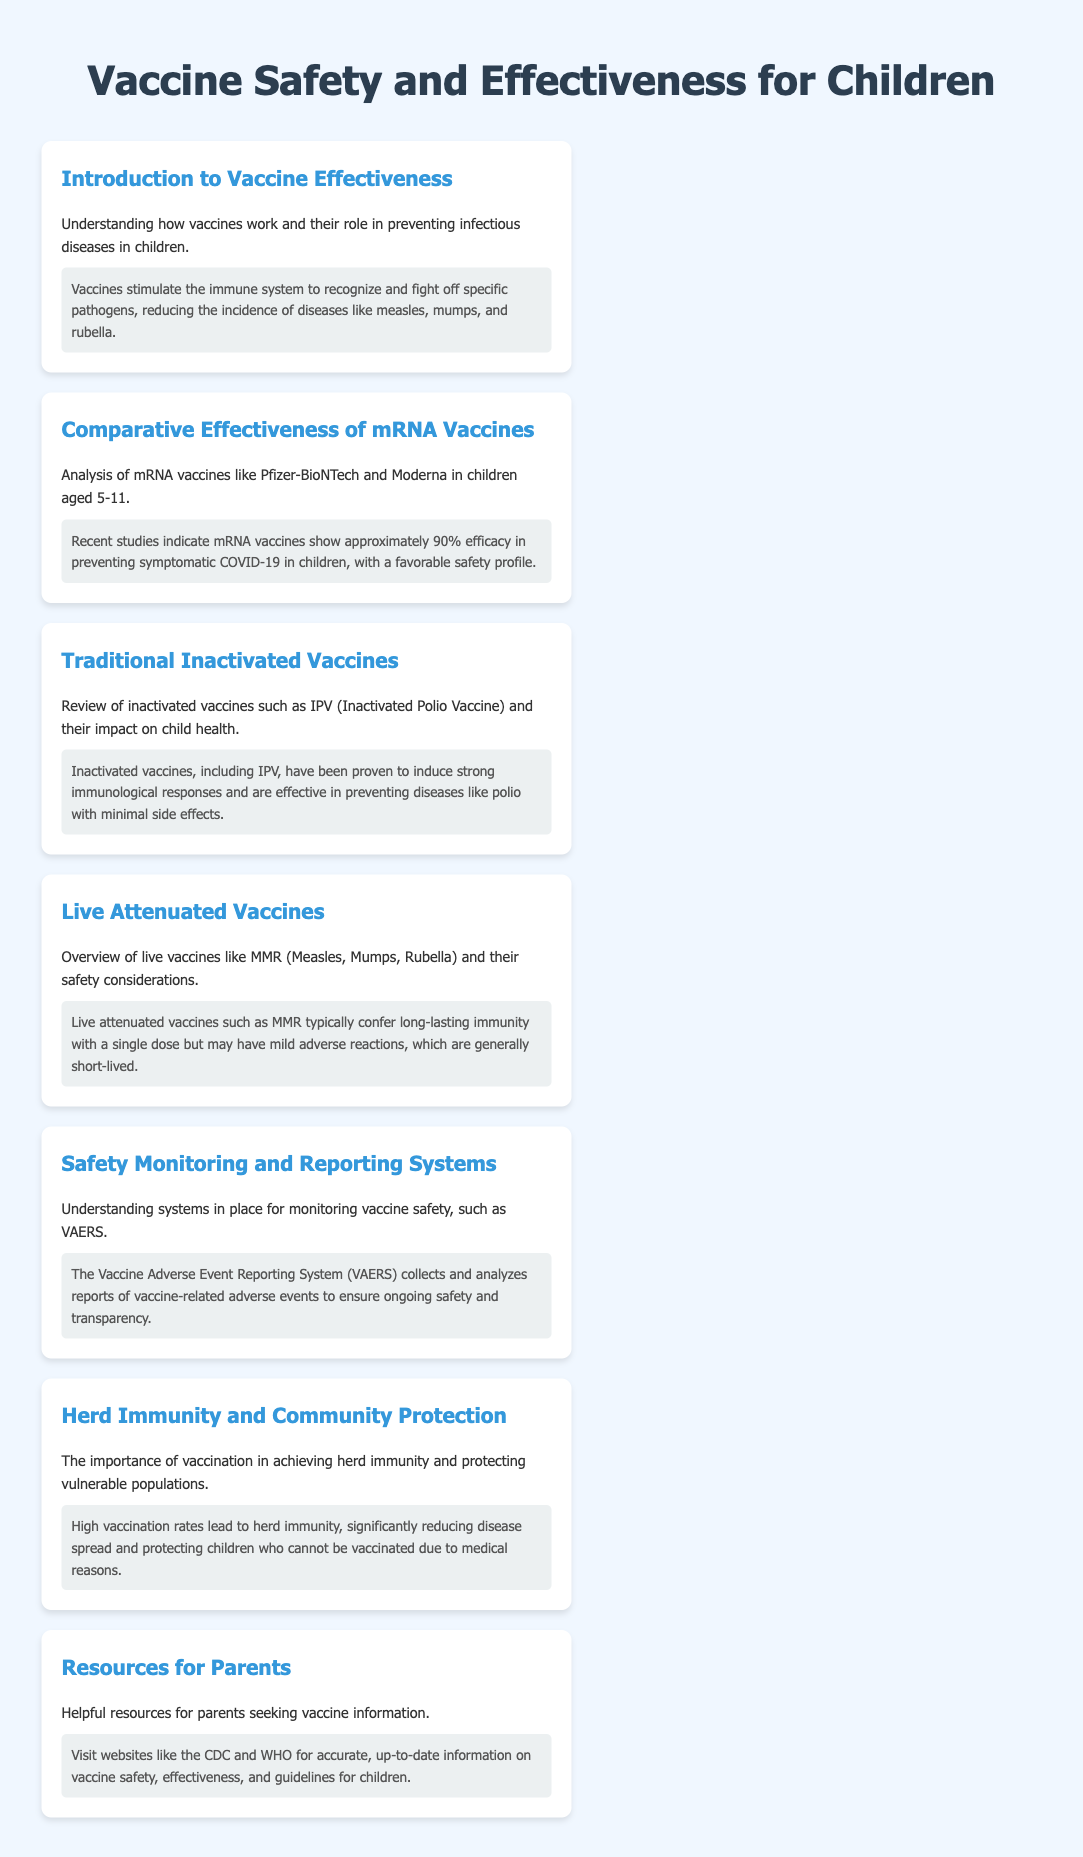What is the efficacy of mRNA vaccines in children? The document states that recent studies indicate mRNA vaccines show approximately 90% efficacy in preventing symptomatic COVID-19 in children.
Answer: 90% What type of vaccine is IPV? IPV is referred to as an inactivated vaccine in the document.
Answer: Inactivated What do live attenuated vaccines like MMR confer? The document states that live attenuated vaccines typically confer long-lasting immunity.
Answer: Long-lasting immunity What does VAERS stand for? The document mentions the Vaccine Adverse Event Reporting System, abbreviated as VAERS.
Answer: VAERS What is the main benefit of high vaccination rates? The document indicates that high vaccination rates lead to herd immunity.
Answer: Herd immunity What can be found on resources like the CDC and WHO? The document suggests that these websites offer accurate, up-to-date information on vaccine safety and effectiveness.
Answer: Vaccine safety and effectiveness What is highlighted as a favorable aspect of mRNA vaccines? The document notes that mRNA vaccines have a favorable safety profile.
Answer: Favorable safety profile What type of vaccine is MMR? The document classifies MMR as a live attenuated vaccine.
Answer: Live attenuated 